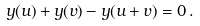Convert formula to latex. <formula><loc_0><loc_0><loc_500><loc_500>y ( u ) + y ( v ) - y ( u + v ) = 0 \, .</formula> 